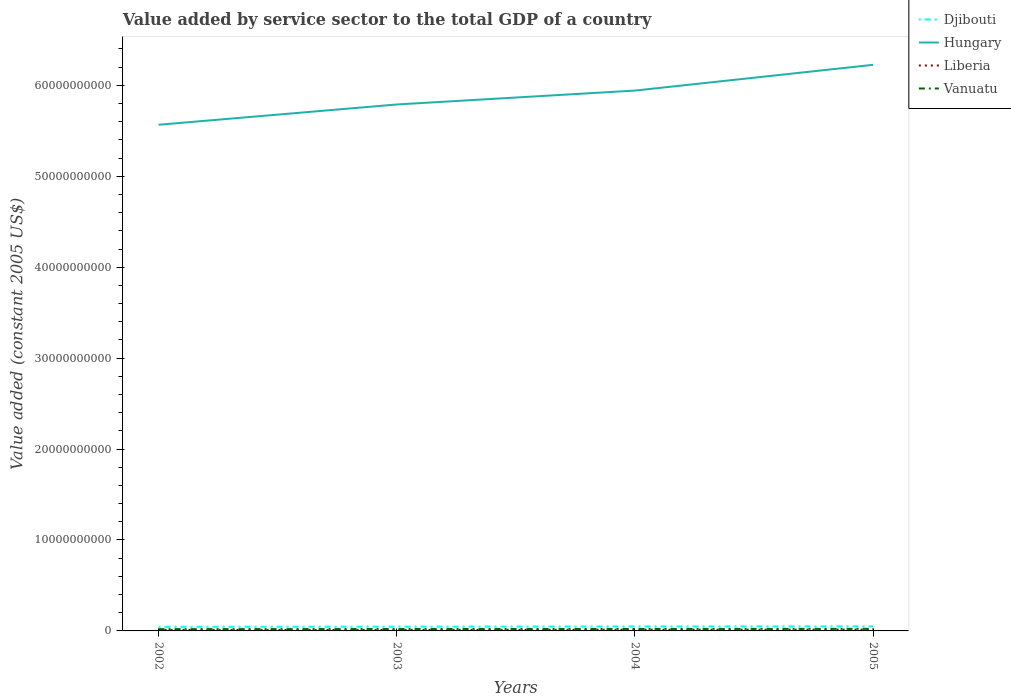Does the line corresponding to Liberia intersect with the line corresponding to Djibouti?
Offer a terse response. No. Is the number of lines equal to the number of legend labels?
Provide a short and direct response. Yes. Across all years, what is the maximum value added by service sector in Djibouti?
Your answer should be very brief. 4.52e+08. In which year was the value added by service sector in Vanuatu maximum?
Your answer should be compact. 2002. What is the total value added by service sector in Hungary in the graph?
Provide a succinct answer. -2.23e+09. What is the difference between the highest and the second highest value added by service sector in Liberia?
Provide a short and direct response. 3.57e+07. Is the value added by service sector in Hungary strictly greater than the value added by service sector in Djibouti over the years?
Your response must be concise. No. How many years are there in the graph?
Offer a terse response. 4. What is the difference between two consecutive major ticks on the Y-axis?
Ensure brevity in your answer.  1.00e+1. Are the values on the major ticks of Y-axis written in scientific E-notation?
Ensure brevity in your answer.  No. Does the graph contain grids?
Make the answer very short. No. Where does the legend appear in the graph?
Your answer should be very brief. Top right. How are the legend labels stacked?
Offer a terse response. Vertical. What is the title of the graph?
Ensure brevity in your answer.  Value added by service sector to the total GDP of a country. Does "Albania" appear as one of the legend labels in the graph?
Your response must be concise. No. What is the label or title of the Y-axis?
Your response must be concise. Value added (constant 2005 US$). What is the Value added (constant 2005 US$) in Djibouti in 2002?
Keep it short and to the point. 4.52e+08. What is the Value added (constant 2005 US$) in Hungary in 2002?
Offer a terse response. 5.57e+1. What is the Value added (constant 2005 US$) in Liberia in 2002?
Make the answer very short. 1.13e+08. What is the Value added (constant 2005 US$) of Vanuatu in 2002?
Make the answer very short. 1.94e+08. What is the Value added (constant 2005 US$) in Djibouti in 2003?
Keep it short and to the point. 4.67e+08. What is the Value added (constant 2005 US$) in Hungary in 2003?
Provide a succinct answer. 5.79e+1. What is the Value added (constant 2005 US$) of Liberia in 2003?
Your answer should be compact. 1.11e+08. What is the Value added (constant 2005 US$) in Vanuatu in 2003?
Provide a short and direct response. 2.08e+08. What is the Value added (constant 2005 US$) of Djibouti in 2004?
Ensure brevity in your answer.  4.91e+08. What is the Value added (constant 2005 US$) in Hungary in 2004?
Your answer should be very brief. 5.94e+1. What is the Value added (constant 2005 US$) of Liberia in 2004?
Your answer should be very brief. 1.35e+08. What is the Value added (constant 2005 US$) in Vanuatu in 2004?
Offer a very short reply. 2.16e+08. What is the Value added (constant 2005 US$) of Djibouti in 2005?
Offer a terse response. 5.04e+08. What is the Value added (constant 2005 US$) of Hungary in 2005?
Your answer should be very brief. 6.23e+1. What is the Value added (constant 2005 US$) in Liberia in 2005?
Provide a short and direct response. 1.47e+08. What is the Value added (constant 2005 US$) of Vanuatu in 2005?
Make the answer very short. 2.29e+08. Across all years, what is the maximum Value added (constant 2005 US$) of Djibouti?
Give a very brief answer. 5.04e+08. Across all years, what is the maximum Value added (constant 2005 US$) of Hungary?
Keep it short and to the point. 6.23e+1. Across all years, what is the maximum Value added (constant 2005 US$) of Liberia?
Provide a short and direct response. 1.47e+08. Across all years, what is the maximum Value added (constant 2005 US$) of Vanuatu?
Keep it short and to the point. 2.29e+08. Across all years, what is the minimum Value added (constant 2005 US$) of Djibouti?
Ensure brevity in your answer.  4.52e+08. Across all years, what is the minimum Value added (constant 2005 US$) of Hungary?
Keep it short and to the point. 5.57e+1. Across all years, what is the minimum Value added (constant 2005 US$) of Liberia?
Your answer should be very brief. 1.11e+08. Across all years, what is the minimum Value added (constant 2005 US$) in Vanuatu?
Provide a succinct answer. 1.94e+08. What is the total Value added (constant 2005 US$) in Djibouti in the graph?
Make the answer very short. 1.91e+09. What is the total Value added (constant 2005 US$) in Hungary in the graph?
Your answer should be very brief. 2.35e+11. What is the total Value added (constant 2005 US$) in Liberia in the graph?
Ensure brevity in your answer.  5.07e+08. What is the total Value added (constant 2005 US$) in Vanuatu in the graph?
Give a very brief answer. 8.47e+08. What is the difference between the Value added (constant 2005 US$) in Djibouti in 2002 and that in 2003?
Your answer should be very brief. -1.53e+07. What is the difference between the Value added (constant 2005 US$) of Hungary in 2002 and that in 2003?
Offer a terse response. -2.23e+09. What is the difference between the Value added (constant 2005 US$) in Liberia in 2002 and that in 2003?
Make the answer very short. 1.74e+06. What is the difference between the Value added (constant 2005 US$) in Vanuatu in 2002 and that in 2003?
Make the answer very short. -1.33e+07. What is the difference between the Value added (constant 2005 US$) in Djibouti in 2002 and that in 2004?
Offer a very short reply. -3.95e+07. What is the difference between the Value added (constant 2005 US$) of Hungary in 2002 and that in 2004?
Your answer should be very brief. -3.76e+09. What is the difference between the Value added (constant 2005 US$) of Liberia in 2002 and that in 2004?
Provide a short and direct response. -2.21e+07. What is the difference between the Value added (constant 2005 US$) in Vanuatu in 2002 and that in 2004?
Provide a short and direct response. -2.20e+07. What is the difference between the Value added (constant 2005 US$) of Djibouti in 2002 and that in 2005?
Offer a terse response. -5.20e+07. What is the difference between the Value added (constant 2005 US$) of Hungary in 2002 and that in 2005?
Provide a short and direct response. -6.59e+09. What is the difference between the Value added (constant 2005 US$) in Liberia in 2002 and that in 2005?
Provide a short and direct response. -3.39e+07. What is the difference between the Value added (constant 2005 US$) in Vanuatu in 2002 and that in 2005?
Your answer should be very brief. -3.43e+07. What is the difference between the Value added (constant 2005 US$) of Djibouti in 2003 and that in 2004?
Ensure brevity in your answer.  -2.43e+07. What is the difference between the Value added (constant 2005 US$) in Hungary in 2003 and that in 2004?
Provide a short and direct response. -1.53e+09. What is the difference between the Value added (constant 2005 US$) of Liberia in 2003 and that in 2004?
Offer a very short reply. -2.39e+07. What is the difference between the Value added (constant 2005 US$) of Vanuatu in 2003 and that in 2004?
Your response must be concise. -8.66e+06. What is the difference between the Value added (constant 2005 US$) in Djibouti in 2003 and that in 2005?
Your answer should be very brief. -3.67e+07. What is the difference between the Value added (constant 2005 US$) in Hungary in 2003 and that in 2005?
Your answer should be very brief. -4.36e+09. What is the difference between the Value added (constant 2005 US$) of Liberia in 2003 and that in 2005?
Provide a short and direct response. -3.57e+07. What is the difference between the Value added (constant 2005 US$) in Vanuatu in 2003 and that in 2005?
Your response must be concise. -2.10e+07. What is the difference between the Value added (constant 2005 US$) in Djibouti in 2004 and that in 2005?
Ensure brevity in your answer.  -1.25e+07. What is the difference between the Value added (constant 2005 US$) in Hungary in 2004 and that in 2005?
Offer a very short reply. -2.83e+09. What is the difference between the Value added (constant 2005 US$) of Liberia in 2004 and that in 2005?
Offer a very short reply. -1.18e+07. What is the difference between the Value added (constant 2005 US$) of Vanuatu in 2004 and that in 2005?
Provide a succinct answer. -1.24e+07. What is the difference between the Value added (constant 2005 US$) in Djibouti in 2002 and the Value added (constant 2005 US$) in Hungary in 2003?
Your answer should be compact. -5.74e+1. What is the difference between the Value added (constant 2005 US$) of Djibouti in 2002 and the Value added (constant 2005 US$) of Liberia in 2003?
Your answer should be very brief. 3.40e+08. What is the difference between the Value added (constant 2005 US$) in Djibouti in 2002 and the Value added (constant 2005 US$) in Vanuatu in 2003?
Offer a very short reply. 2.44e+08. What is the difference between the Value added (constant 2005 US$) of Hungary in 2002 and the Value added (constant 2005 US$) of Liberia in 2003?
Your answer should be compact. 5.56e+1. What is the difference between the Value added (constant 2005 US$) in Hungary in 2002 and the Value added (constant 2005 US$) in Vanuatu in 2003?
Your answer should be very brief. 5.55e+1. What is the difference between the Value added (constant 2005 US$) of Liberia in 2002 and the Value added (constant 2005 US$) of Vanuatu in 2003?
Give a very brief answer. -9.45e+07. What is the difference between the Value added (constant 2005 US$) of Djibouti in 2002 and the Value added (constant 2005 US$) of Hungary in 2004?
Provide a short and direct response. -5.90e+1. What is the difference between the Value added (constant 2005 US$) in Djibouti in 2002 and the Value added (constant 2005 US$) in Liberia in 2004?
Make the answer very short. 3.16e+08. What is the difference between the Value added (constant 2005 US$) in Djibouti in 2002 and the Value added (constant 2005 US$) in Vanuatu in 2004?
Provide a succinct answer. 2.35e+08. What is the difference between the Value added (constant 2005 US$) in Hungary in 2002 and the Value added (constant 2005 US$) in Liberia in 2004?
Your answer should be very brief. 5.55e+1. What is the difference between the Value added (constant 2005 US$) of Hungary in 2002 and the Value added (constant 2005 US$) of Vanuatu in 2004?
Keep it short and to the point. 5.54e+1. What is the difference between the Value added (constant 2005 US$) in Liberia in 2002 and the Value added (constant 2005 US$) in Vanuatu in 2004?
Offer a very short reply. -1.03e+08. What is the difference between the Value added (constant 2005 US$) in Djibouti in 2002 and the Value added (constant 2005 US$) in Hungary in 2005?
Your answer should be compact. -6.18e+1. What is the difference between the Value added (constant 2005 US$) of Djibouti in 2002 and the Value added (constant 2005 US$) of Liberia in 2005?
Provide a short and direct response. 3.05e+08. What is the difference between the Value added (constant 2005 US$) of Djibouti in 2002 and the Value added (constant 2005 US$) of Vanuatu in 2005?
Provide a succinct answer. 2.23e+08. What is the difference between the Value added (constant 2005 US$) of Hungary in 2002 and the Value added (constant 2005 US$) of Liberia in 2005?
Provide a succinct answer. 5.55e+1. What is the difference between the Value added (constant 2005 US$) in Hungary in 2002 and the Value added (constant 2005 US$) in Vanuatu in 2005?
Your answer should be compact. 5.54e+1. What is the difference between the Value added (constant 2005 US$) of Liberia in 2002 and the Value added (constant 2005 US$) of Vanuatu in 2005?
Your response must be concise. -1.16e+08. What is the difference between the Value added (constant 2005 US$) of Djibouti in 2003 and the Value added (constant 2005 US$) of Hungary in 2004?
Offer a very short reply. -5.90e+1. What is the difference between the Value added (constant 2005 US$) in Djibouti in 2003 and the Value added (constant 2005 US$) in Liberia in 2004?
Provide a short and direct response. 3.32e+08. What is the difference between the Value added (constant 2005 US$) of Djibouti in 2003 and the Value added (constant 2005 US$) of Vanuatu in 2004?
Your answer should be compact. 2.51e+08. What is the difference between the Value added (constant 2005 US$) of Hungary in 2003 and the Value added (constant 2005 US$) of Liberia in 2004?
Offer a terse response. 5.78e+1. What is the difference between the Value added (constant 2005 US$) in Hungary in 2003 and the Value added (constant 2005 US$) in Vanuatu in 2004?
Provide a succinct answer. 5.77e+1. What is the difference between the Value added (constant 2005 US$) of Liberia in 2003 and the Value added (constant 2005 US$) of Vanuatu in 2004?
Give a very brief answer. -1.05e+08. What is the difference between the Value added (constant 2005 US$) of Djibouti in 2003 and the Value added (constant 2005 US$) of Hungary in 2005?
Make the answer very short. -6.18e+1. What is the difference between the Value added (constant 2005 US$) of Djibouti in 2003 and the Value added (constant 2005 US$) of Liberia in 2005?
Keep it short and to the point. 3.20e+08. What is the difference between the Value added (constant 2005 US$) in Djibouti in 2003 and the Value added (constant 2005 US$) in Vanuatu in 2005?
Keep it short and to the point. 2.38e+08. What is the difference between the Value added (constant 2005 US$) in Hungary in 2003 and the Value added (constant 2005 US$) in Liberia in 2005?
Provide a short and direct response. 5.77e+1. What is the difference between the Value added (constant 2005 US$) in Hungary in 2003 and the Value added (constant 2005 US$) in Vanuatu in 2005?
Your answer should be compact. 5.77e+1. What is the difference between the Value added (constant 2005 US$) in Liberia in 2003 and the Value added (constant 2005 US$) in Vanuatu in 2005?
Make the answer very short. -1.17e+08. What is the difference between the Value added (constant 2005 US$) of Djibouti in 2004 and the Value added (constant 2005 US$) of Hungary in 2005?
Ensure brevity in your answer.  -6.18e+1. What is the difference between the Value added (constant 2005 US$) of Djibouti in 2004 and the Value added (constant 2005 US$) of Liberia in 2005?
Your answer should be compact. 3.44e+08. What is the difference between the Value added (constant 2005 US$) in Djibouti in 2004 and the Value added (constant 2005 US$) in Vanuatu in 2005?
Make the answer very short. 2.62e+08. What is the difference between the Value added (constant 2005 US$) of Hungary in 2004 and the Value added (constant 2005 US$) of Liberia in 2005?
Your answer should be very brief. 5.93e+1. What is the difference between the Value added (constant 2005 US$) in Hungary in 2004 and the Value added (constant 2005 US$) in Vanuatu in 2005?
Your response must be concise. 5.92e+1. What is the difference between the Value added (constant 2005 US$) in Liberia in 2004 and the Value added (constant 2005 US$) in Vanuatu in 2005?
Offer a terse response. -9.34e+07. What is the average Value added (constant 2005 US$) in Djibouti per year?
Ensure brevity in your answer.  4.78e+08. What is the average Value added (constant 2005 US$) of Hungary per year?
Ensure brevity in your answer.  5.88e+1. What is the average Value added (constant 2005 US$) of Liberia per year?
Offer a terse response. 1.27e+08. What is the average Value added (constant 2005 US$) of Vanuatu per year?
Provide a succinct answer. 2.12e+08. In the year 2002, what is the difference between the Value added (constant 2005 US$) in Djibouti and Value added (constant 2005 US$) in Hungary?
Make the answer very short. -5.52e+1. In the year 2002, what is the difference between the Value added (constant 2005 US$) in Djibouti and Value added (constant 2005 US$) in Liberia?
Provide a short and direct response. 3.38e+08. In the year 2002, what is the difference between the Value added (constant 2005 US$) of Djibouti and Value added (constant 2005 US$) of Vanuatu?
Your answer should be very brief. 2.57e+08. In the year 2002, what is the difference between the Value added (constant 2005 US$) of Hungary and Value added (constant 2005 US$) of Liberia?
Offer a terse response. 5.56e+1. In the year 2002, what is the difference between the Value added (constant 2005 US$) in Hungary and Value added (constant 2005 US$) in Vanuatu?
Offer a terse response. 5.55e+1. In the year 2002, what is the difference between the Value added (constant 2005 US$) of Liberia and Value added (constant 2005 US$) of Vanuatu?
Keep it short and to the point. -8.12e+07. In the year 2003, what is the difference between the Value added (constant 2005 US$) in Djibouti and Value added (constant 2005 US$) in Hungary?
Offer a terse response. -5.74e+1. In the year 2003, what is the difference between the Value added (constant 2005 US$) in Djibouti and Value added (constant 2005 US$) in Liberia?
Offer a terse response. 3.55e+08. In the year 2003, what is the difference between the Value added (constant 2005 US$) in Djibouti and Value added (constant 2005 US$) in Vanuatu?
Your response must be concise. 2.59e+08. In the year 2003, what is the difference between the Value added (constant 2005 US$) of Hungary and Value added (constant 2005 US$) of Liberia?
Your answer should be very brief. 5.78e+1. In the year 2003, what is the difference between the Value added (constant 2005 US$) of Hungary and Value added (constant 2005 US$) of Vanuatu?
Your answer should be compact. 5.77e+1. In the year 2003, what is the difference between the Value added (constant 2005 US$) of Liberia and Value added (constant 2005 US$) of Vanuatu?
Keep it short and to the point. -9.62e+07. In the year 2004, what is the difference between the Value added (constant 2005 US$) of Djibouti and Value added (constant 2005 US$) of Hungary?
Offer a very short reply. -5.89e+1. In the year 2004, what is the difference between the Value added (constant 2005 US$) in Djibouti and Value added (constant 2005 US$) in Liberia?
Your answer should be very brief. 3.56e+08. In the year 2004, what is the difference between the Value added (constant 2005 US$) of Djibouti and Value added (constant 2005 US$) of Vanuatu?
Provide a short and direct response. 2.75e+08. In the year 2004, what is the difference between the Value added (constant 2005 US$) of Hungary and Value added (constant 2005 US$) of Liberia?
Offer a terse response. 5.93e+1. In the year 2004, what is the difference between the Value added (constant 2005 US$) of Hungary and Value added (constant 2005 US$) of Vanuatu?
Make the answer very short. 5.92e+1. In the year 2004, what is the difference between the Value added (constant 2005 US$) in Liberia and Value added (constant 2005 US$) in Vanuatu?
Provide a succinct answer. -8.10e+07. In the year 2005, what is the difference between the Value added (constant 2005 US$) in Djibouti and Value added (constant 2005 US$) in Hungary?
Give a very brief answer. -6.18e+1. In the year 2005, what is the difference between the Value added (constant 2005 US$) of Djibouti and Value added (constant 2005 US$) of Liberia?
Give a very brief answer. 3.57e+08. In the year 2005, what is the difference between the Value added (constant 2005 US$) in Djibouti and Value added (constant 2005 US$) in Vanuatu?
Provide a short and direct response. 2.75e+08. In the year 2005, what is the difference between the Value added (constant 2005 US$) in Hungary and Value added (constant 2005 US$) in Liberia?
Make the answer very short. 6.21e+1. In the year 2005, what is the difference between the Value added (constant 2005 US$) in Hungary and Value added (constant 2005 US$) in Vanuatu?
Your answer should be compact. 6.20e+1. In the year 2005, what is the difference between the Value added (constant 2005 US$) in Liberia and Value added (constant 2005 US$) in Vanuatu?
Ensure brevity in your answer.  -8.16e+07. What is the ratio of the Value added (constant 2005 US$) of Djibouti in 2002 to that in 2003?
Make the answer very short. 0.97. What is the ratio of the Value added (constant 2005 US$) in Hungary in 2002 to that in 2003?
Your answer should be very brief. 0.96. What is the ratio of the Value added (constant 2005 US$) in Liberia in 2002 to that in 2003?
Ensure brevity in your answer.  1.02. What is the ratio of the Value added (constant 2005 US$) in Vanuatu in 2002 to that in 2003?
Your answer should be compact. 0.94. What is the ratio of the Value added (constant 2005 US$) of Djibouti in 2002 to that in 2004?
Offer a terse response. 0.92. What is the ratio of the Value added (constant 2005 US$) in Hungary in 2002 to that in 2004?
Offer a terse response. 0.94. What is the ratio of the Value added (constant 2005 US$) in Liberia in 2002 to that in 2004?
Your response must be concise. 0.84. What is the ratio of the Value added (constant 2005 US$) of Vanuatu in 2002 to that in 2004?
Make the answer very short. 0.9. What is the ratio of the Value added (constant 2005 US$) of Djibouti in 2002 to that in 2005?
Keep it short and to the point. 0.9. What is the ratio of the Value added (constant 2005 US$) in Hungary in 2002 to that in 2005?
Offer a terse response. 0.89. What is the ratio of the Value added (constant 2005 US$) in Liberia in 2002 to that in 2005?
Make the answer very short. 0.77. What is the ratio of the Value added (constant 2005 US$) in Vanuatu in 2002 to that in 2005?
Your answer should be very brief. 0.85. What is the ratio of the Value added (constant 2005 US$) of Djibouti in 2003 to that in 2004?
Give a very brief answer. 0.95. What is the ratio of the Value added (constant 2005 US$) in Hungary in 2003 to that in 2004?
Keep it short and to the point. 0.97. What is the ratio of the Value added (constant 2005 US$) in Liberia in 2003 to that in 2004?
Provide a succinct answer. 0.82. What is the ratio of the Value added (constant 2005 US$) in Djibouti in 2003 to that in 2005?
Your answer should be very brief. 0.93. What is the ratio of the Value added (constant 2005 US$) in Liberia in 2003 to that in 2005?
Give a very brief answer. 0.76. What is the ratio of the Value added (constant 2005 US$) in Vanuatu in 2003 to that in 2005?
Your answer should be compact. 0.91. What is the ratio of the Value added (constant 2005 US$) in Djibouti in 2004 to that in 2005?
Provide a succinct answer. 0.98. What is the ratio of the Value added (constant 2005 US$) of Hungary in 2004 to that in 2005?
Provide a succinct answer. 0.95. What is the ratio of the Value added (constant 2005 US$) of Liberia in 2004 to that in 2005?
Provide a succinct answer. 0.92. What is the ratio of the Value added (constant 2005 US$) of Vanuatu in 2004 to that in 2005?
Offer a very short reply. 0.95. What is the difference between the highest and the second highest Value added (constant 2005 US$) in Djibouti?
Ensure brevity in your answer.  1.25e+07. What is the difference between the highest and the second highest Value added (constant 2005 US$) of Hungary?
Provide a short and direct response. 2.83e+09. What is the difference between the highest and the second highest Value added (constant 2005 US$) of Liberia?
Give a very brief answer. 1.18e+07. What is the difference between the highest and the second highest Value added (constant 2005 US$) of Vanuatu?
Your response must be concise. 1.24e+07. What is the difference between the highest and the lowest Value added (constant 2005 US$) in Djibouti?
Ensure brevity in your answer.  5.20e+07. What is the difference between the highest and the lowest Value added (constant 2005 US$) in Hungary?
Provide a short and direct response. 6.59e+09. What is the difference between the highest and the lowest Value added (constant 2005 US$) of Liberia?
Ensure brevity in your answer.  3.57e+07. What is the difference between the highest and the lowest Value added (constant 2005 US$) in Vanuatu?
Your response must be concise. 3.43e+07. 